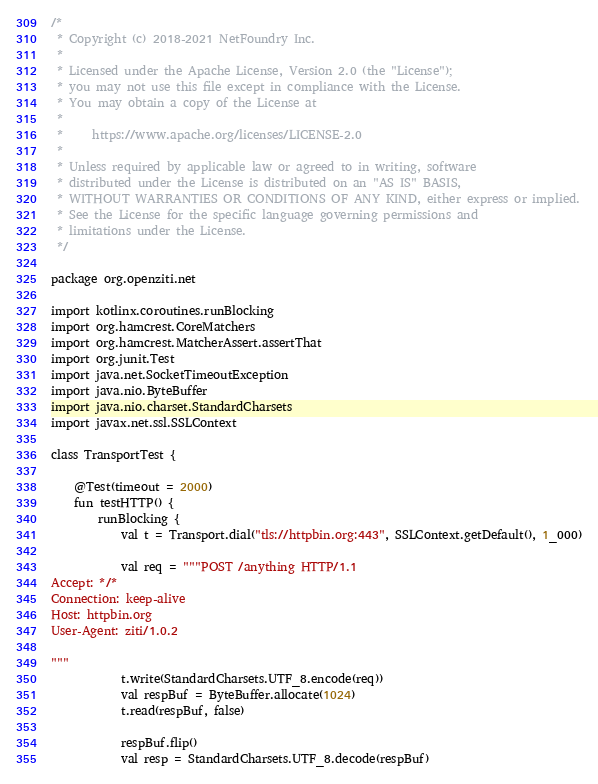<code> <loc_0><loc_0><loc_500><loc_500><_Kotlin_>/*
 * Copyright (c) 2018-2021 NetFoundry Inc.
 *
 * Licensed under the Apache License, Version 2.0 (the "License");
 * you may not use this file except in compliance with the License.
 * You may obtain a copy of the License at
 *
 *     https://www.apache.org/licenses/LICENSE-2.0
 *
 * Unless required by applicable law or agreed to in writing, software
 * distributed under the License is distributed on an "AS IS" BASIS,
 * WITHOUT WARRANTIES OR CONDITIONS OF ANY KIND, either express or implied.
 * See the License for the specific language governing permissions and
 * limitations under the License.
 */

package org.openziti.net

import kotlinx.coroutines.runBlocking
import org.hamcrest.CoreMatchers
import org.hamcrest.MatcherAssert.assertThat
import org.junit.Test
import java.net.SocketTimeoutException
import java.nio.ByteBuffer
import java.nio.charset.StandardCharsets
import javax.net.ssl.SSLContext

class TransportTest {

    @Test(timeout = 2000)
    fun testHTTP() {
        runBlocking {
            val t = Transport.dial("tls://httpbin.org:443", SSLContext.getDefault(), 1_000)

            val req = """POST /anything HTTP/1.1
Accept: */*
Connection: keep-alive
Host: httpbin.org
User-Agent: ziti/1.0.2

"""
            t.write(StandardCharsets.UTF_8.encode(req))
            val respBuf = ByteBuffer.allocate(1024)
            t.read(respBuf, false)

            respBuf.flip()
            val resp = StandardCharsets.UTF_8.decode(respBuf)</code> 